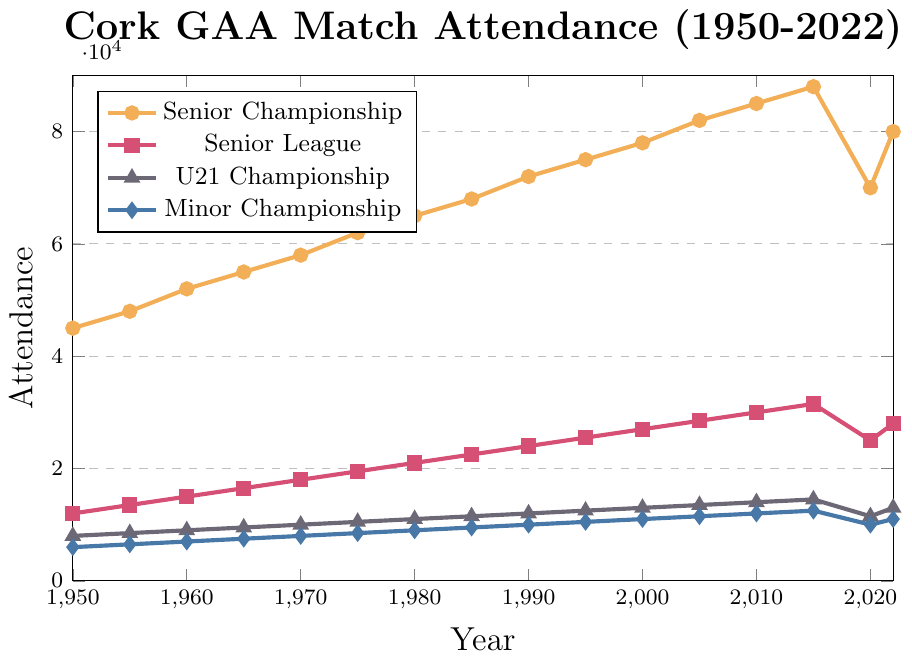Which year had the highest attendance for the Senior Championship? Locate the highest point on the Senior Championship line (cork1 color) on the chart. This point occurs in 2015.
Answer: 2015 How did the attendance for the Minor Championship change between 2020 and 2022? Identify the attendance figures for Minor Championship in both 2020 and 2022. Attendance increased from 10000 in 2020 to 11000 in 2022.
Answer: Increased by 1000 Compare the attendance for the Senior League and U21 Championship in 1980. Which was higher and by how much? Locate the points for both Senior League and U21 Championship in 1980. Senior League had 21000 attendees while U21 Championship had 11000. The difference is 21000 - 11000 = 10000.
Answer: Senior League by 10000 What is the trend of the Senior Championship attendance from 1950 to 2015? Observe the line representing the Senior Championship from 1950 to 2015. The attendance steadily increases over this period.
Answer: Steady increase Which competition had the least attendance in 1975? Review the attendance of all competitions in 1975. The Minor Championship had the lowest attendance with 8500 attendees.
Answer: Minor Championship What was the average attendance for the Senior Championship over the entire time period? Sum the Senior Championship attendance from 1950 to 2022 and divide by the number of years (16). (45000+48000+52000+55000+58000+62000+65000+68000+72000+75000+78000+82000+85000+88000+70000+80000)/16 = 65500.
Answer: 65500 By how much did the attendance for the U21 Championship increase from 1950 to 2000? Find the attendance for the U21 Championship in 1950 and 2000 and then calculate the difference. Attendance in 1950 was 8000, and in 2000 it was 13000. The difference is 13000 - 8000 = 5000.
Answer: 5000 Was there ever a year where all competitions saw a decrease in attendance from the previous year? Check the trend lines of all competitions year by year. In 2020, all competitions saw a decrease compared to the previous year (2015).
Answer: Yes, in 2020 Which competition had the highest attendance growth rate from 1960 to 1970? Calculate the growth rate for each competition from 1960 to 1970. Senior Championship grew from 52000 to 58000 (6000 increase), Senior League from 15000 to 18000 (3000 increase), U21 Championship from 9000 to 10000 (1000 increase), Minor Championship from 7000 to 8000 (1000 increase). The Senior Championship had the highest growth rate.
Answer: Senior Championship 